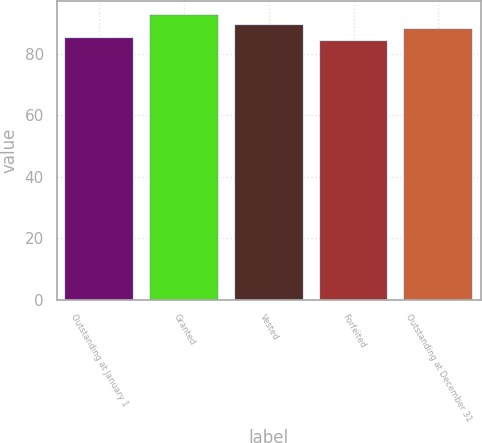Convert chart. <chart><loc_0><loc_0><loc_500><loc_500><bar_chart><fcel>Outstanding at January 1<fcel>Granted<fcel>Vested<fcel>Forfeited<fcel>Outstanding at December 31<nl><fcel>85.12<fcel>92.46<fcel>89.3<fcel>84.17<fcel>87.86<nl></chart> 